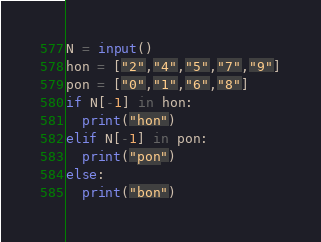<code> <loc_0><loc_0><loc_500><loc_500><_Python_>N = input()
hon = ["2","4","5","7","9"]
pon = ["0","1","6","8"]
if N[-1] in hon:
  print("hon")
elif N[-1] in pon:
  print("pon")
else:
  print("bon")</code> 